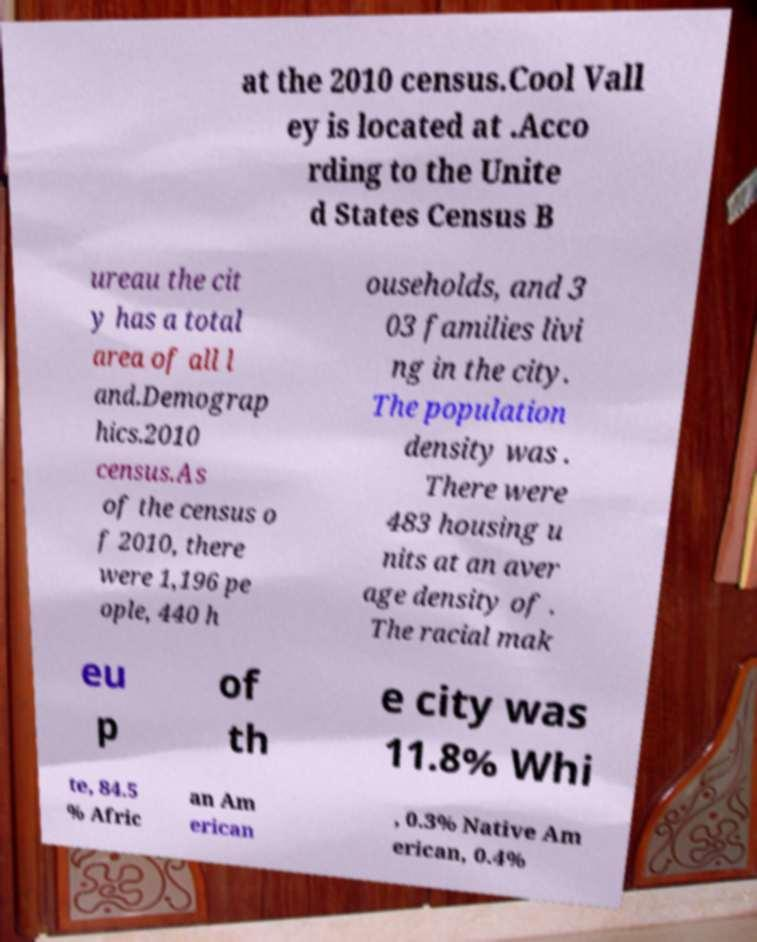I need the written content from this picture converted into text. Can you do that? at the 2010 census.Cool Vall ey is located at .Acco rding to the Unite d States Census B ureau the cit y has a total area of all l and.Demograp hics.2010 census.As of the census o f 2010, there were 1,196 pe ople, 440 h ouseholds, and 3 03 families livi ng in the city. The population density was . There were 483 housing u nits at an aver age density of . The racial mak eu p of th e city was 11.8% Whi te, 84.5 % Afric an Am erican , 0.3% Native Am erican, 0.4% 